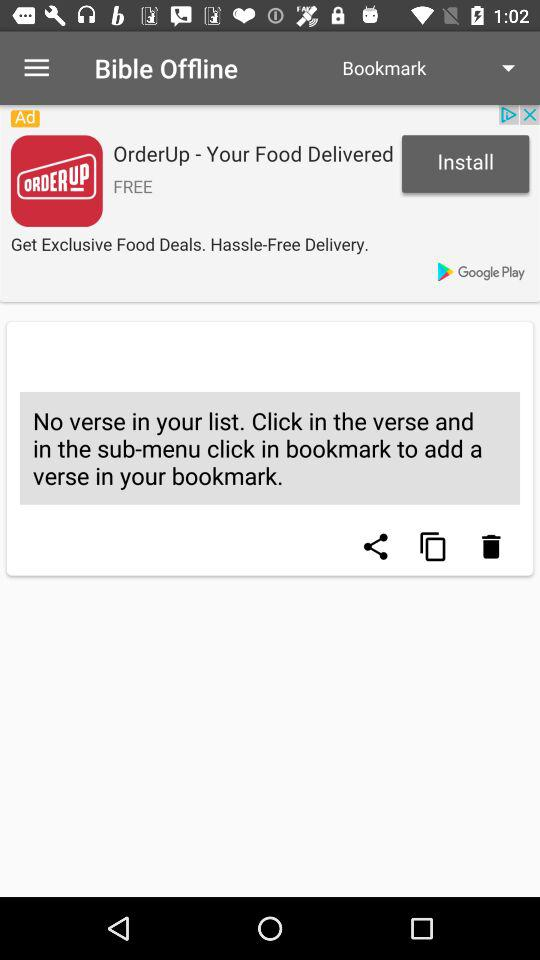What is the name of the application? The name of the application is "Bible Offline". 